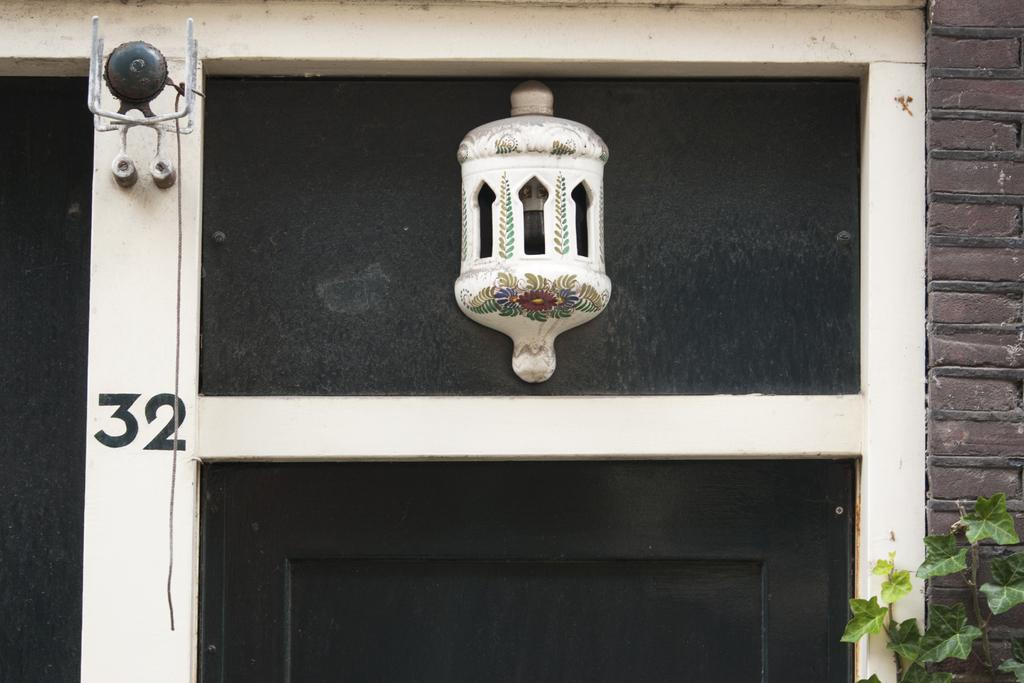What is one of the main objects in the image? There is a door in the image. What is connected to the door? A ball is attached to the door. What type of structure is visible in the image? There is a wall in the image. What type of living organism is present in the image? There is a plant in the image. What type of request can be seen being made by the plant in the image? There is no indication in the image that the plant is making any request. What stage of development is the ball in the image? The image does not provide information about the development stage of the ball. 